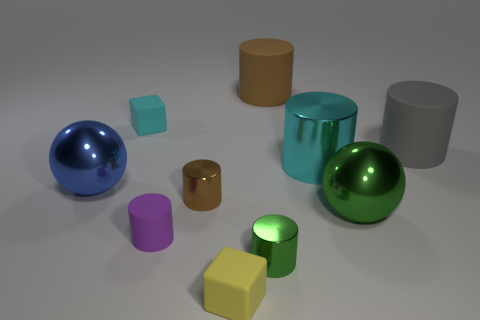What number of objects are small objects to the left of the tiny brown metal thing or cubes?
Keep it short and to the point. 3. What material is the small cyan object?
Offer a very short reply. Rubber. Do the gray thing and the green ball have the same size?
Your answer should be very brief. Yes. How many balls are green metallic things or large shiny objects?
Your answer should be compact. 2. There is a large rubber object to the left of the big rubber cylinder in front of the large brown matte cylinder; what is its color?
Your answer should be very brief. Brown. Is the number of green spheres in front of the green shiny sphere less than the number of tiny yellow blocks behind the big metallic cylinder?
Ensure brevity in your answer.  No. There is a brown metallic cylinder; does it have the same size as the cyan object that is to the left of the brown matte thing?
Offer a very short reply. Yes. What shape is the matte thing that is both in front of the blue ball and on the right side of the tiny purple cylinder?
Make the answer very short. Cube. What size is the gray thing that is the same material as the big brown object?
Make the answer very short. Large. How many rubber blocks are on the right side of the small cyan matte cube that is on the left side of the large green thing?
Give a very brief answer. 1. 